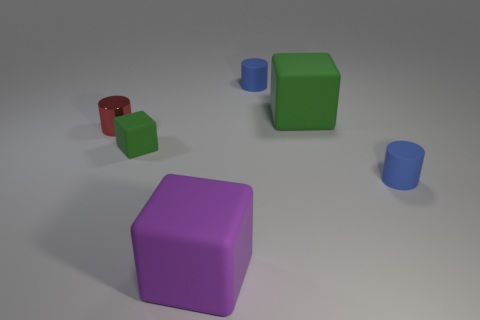Is there another metallic cylinder that has the same color as the small shiny cylinder?
Provide a short and direct response. No. The block that is the same size as the red metallic thing is what color?
Offer a terse response. Green. What number of blue things are in front of the blue rubber object left of the big green matte cube?
Ensure brevity in your answer.  1. What number of things are either small red cylinders behind the tiny green thing or big blocks?
Provide a succinct answer. 3. What number of large purple objects are the same material as the small green object?
Offer a very short reply. 1. There is a big thing that is the same color as the small matte block; what shape is it?
Keep it short and to the point. Cube. Are there the same number of rubber objects that are behind the large green rubber thing and tiny rubber blocks?
Provide a short and direct response. Yes. What size is the green rubber block that is to the left of the purple rubber thing?
Offer a terse response. Small. What number of small objects are green matte objects or purple blocks?
Keep it short and to the point. 1. The other big thing that is the same shape as the big green matte object is what color?
Your response must be concise. Purple. 